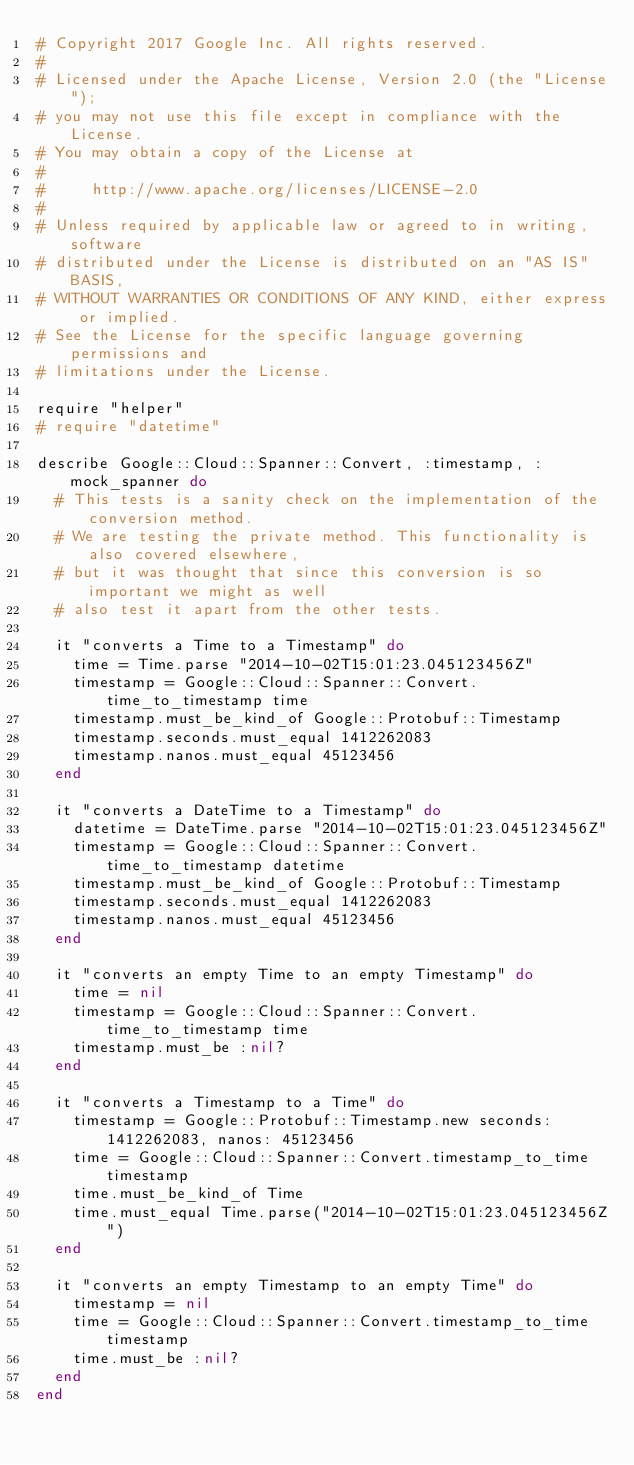<code> <loc_0><loc_0><loc_500><loc_500><_Ruby_># Copyright 2017 Google Inc. All rights reserved.
#
# Licensed under the Apache License, Version 2.0 (the "License");
# you may not use this file except in compliance with the License.
# You may obtain a copy of the License at
#
#     http://www.apache.org/licenses/LICENSE-2.0
#
# Unless required by applicable law or agreed to in writing, software
# distributed under the License is distributed on an "AS IS" BASIS,
# WITHOUT WARRANTIES OR CONDITIONS OF ANY KIND, either express or implied.
# See the License for the specific language governing permissions and
# limitations under the License.

require "helper"
# require "datetime"

describe Google::Cloud::Spanner::Convert, :timestamp, :mock_spanner do
  # This tests is a sanity check on the implementation of the conversion method.
  # We are testing the private method. This functionality is also covered elsewhere,
  # but it was thought that since this conversion is so important we might as well
  # also test it apart from the other tests.

  it "converts a Time to a Timestamp" do
    time = Time.parse "2014-10-02T15:01:23.045123456Z"
    timestamp = Google::Cloud::Spanner::Convert.time_to_timestamp time
    timestamp.must_be_kind_of Google::Protobuf::Timestamp
    timestamp.seconds.must_equal 1412262083
    timestamp.nanos.must_equal 45123456
  end

  it "converts a DateTime to a Timestamp" do
    datetime = DateTime.parse "2014-10-02T15:01:23.045123456Z"
    timestamp = Google::Cloud::Spanner::Convert.time_to_timestamp datetime
    timestamp.must_be_kind_of Google::Protobuf::Timestamp
    timestamp.seconds.must_equal 1412262083
    timestamp.nanos.must_equal 45123456
  end

  it "converts an empty Time to an empty Timestamp" do
    time = nil
    timestamp = Google::Cloud::Spanner::Convert.time_to_timestamp time
    timestamp.must_be :nil?
  end

  it "converts a Timestamp to a Time" do
    timestamp = Google::Protobuf::Timestamp.new seconds: 1412262083, nanos: 45123456
    time = Google::Cloud::Spanner::Convert.timestamp_to_time timestamp
    time.must_be_kind_of Time
    time.must_equal Time.parse("2014-10-02T15:01:23.045123456Z")
  end

  it "converts an empty Timestamp to an empty Time" do
    timestamp = nil
    time = Google::Cloud::Spanner::Convert.timestamp_to_time timestamp
    time.must_be :nil?
  end
end
</code> 